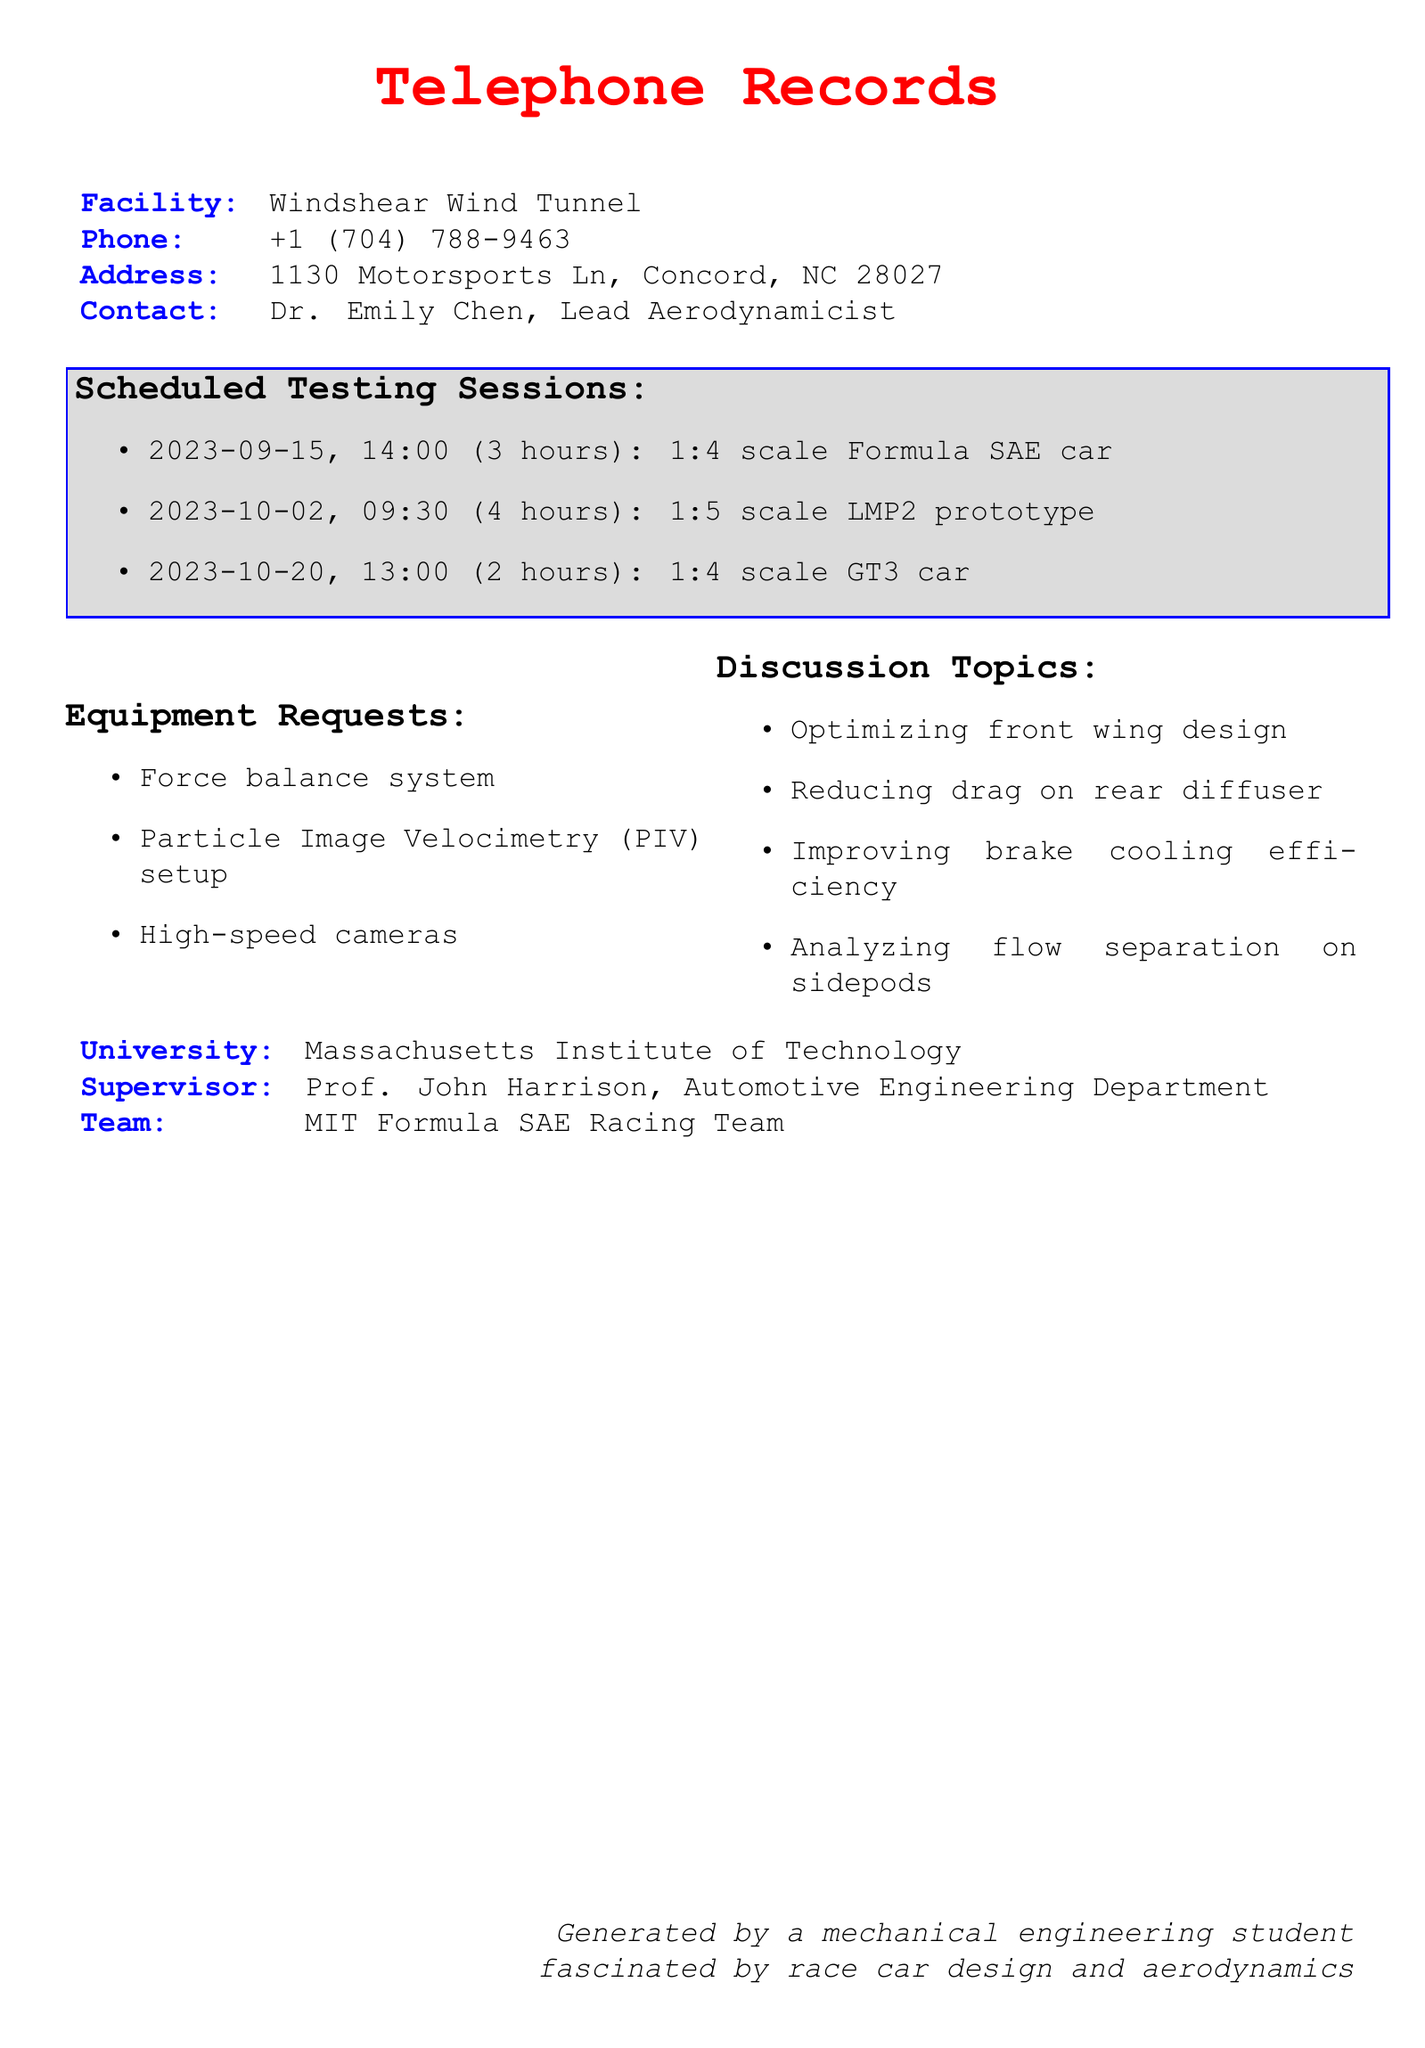What is the name of the wind tunnel facility? The document mentions the wind tunnel facility as Windshear Wind Tunnel.
Answer: Windshear Wind Tunnel Who is the lead aerodynamicist at the facility? According to the document, the contact person is Dr. Emily Chen, who is the Lead Aerodynamicist.
Answer: Dr. Emily Chen What is the date of the first scheduled testing session? The first scheduled testing session is on September 15, 2023.
Answer: 2023-09-15 How long is the testing session for the 1:5 scale LMP2 prototype? The duration of the testing session for the 1:5 scale LMP2 prototype is mentioned as 4 hours.
Answer: 4 hours How many hours are scheduled for the 1:4 scale GT3 car testing? The document specifies that the testing session for the 1:4 scale GT3 car is for 2 hours.
Answer: 2 hours Which university is associated with the scheduled testing sessions? The document lists the university as Massachusetts Institute of Technology.
Answer: Massachusetts Institute of Technology What equipment is requested for the testing sessions? The document mentions three specific equipment requests: a force balance system, a Particle Image Velocimetry setup, and high-speed cameras.
Answer: Force balance system, Particle Image Velocimetry setup, high-speed cameras What is one of the discussion topics related to the testing sessions? The document includes multiple discussion topics, one of which is optimizing front wing design.
Answer: Optimizing front wing design How many scheduled testing sessions are documented? The document outlines a total of three scheduled testing sessions.
Answer: 3 